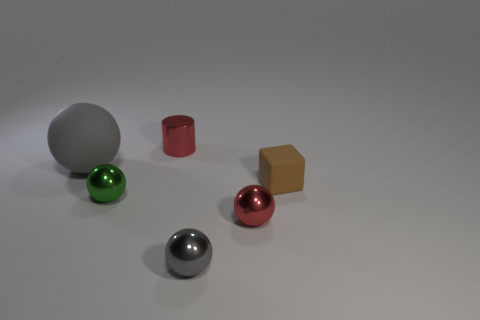Imagine these objects are part of a game, how would you describe the rules based on their arrangement? If these objects were part of a game, we could speculate that the spheres might be used as playing pieces due to their ability to roll, and the positioning suggests a starting line. The silver cylinder could serve as a landmark or goal to aim for, with the gold cube as a high-value target or bonus piece. Players might take turns rolling the spheres towards the silver cylinder, earning points based on proximity, with bonus points if the gold cube is touched without knocking it over. 